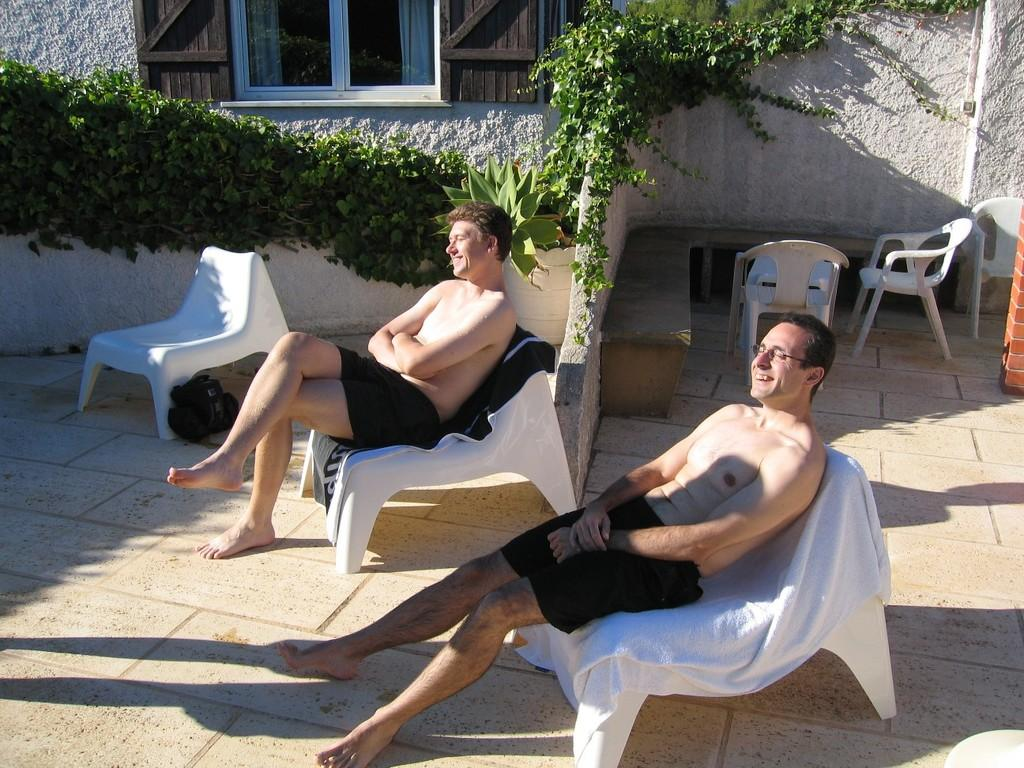How many people are sitting in the image? There are two people sitting on chairs in the image. What is the facial expression of the people in the image? The people are smiling in the image. What can be seen in the background of the image? There are climbers visible in the image. What type of furniture is present in the image? There are chairs in the image. What architectural features can be seen in the image? There is a wall and a window in the image. What is the price of the dock visible in the image? There is no dock present in the image, so it is not possible to determine its price. 